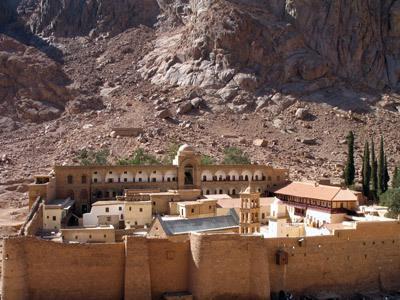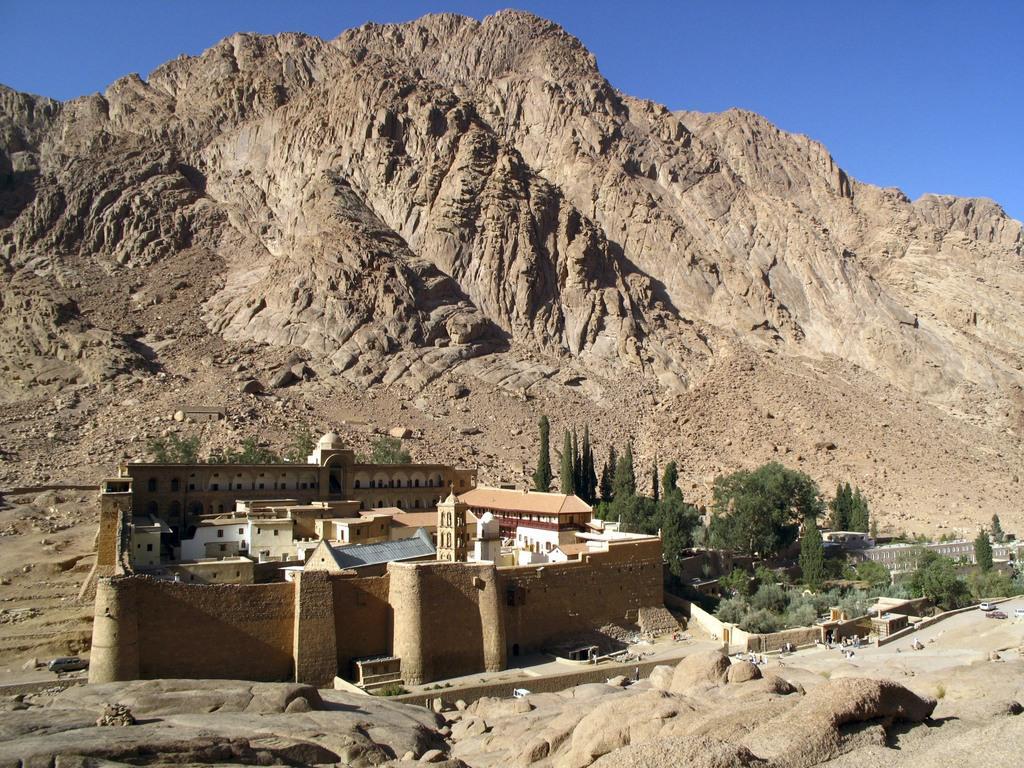The first image is the image on the left, the second image is the image on the right. Evaluate the accuracy of this statement regarding the images: "The left and right image contains a total of two compounds facing forward.". Is it true? Answer yes or no. Yes. The first image is the image on the left, the second image is the image on the right. Assess this claim about the two images: "There is mountain in the bottom right of one image, next to and above the town, but not in the other image.". Correct or not? Answer yes or no. No. 